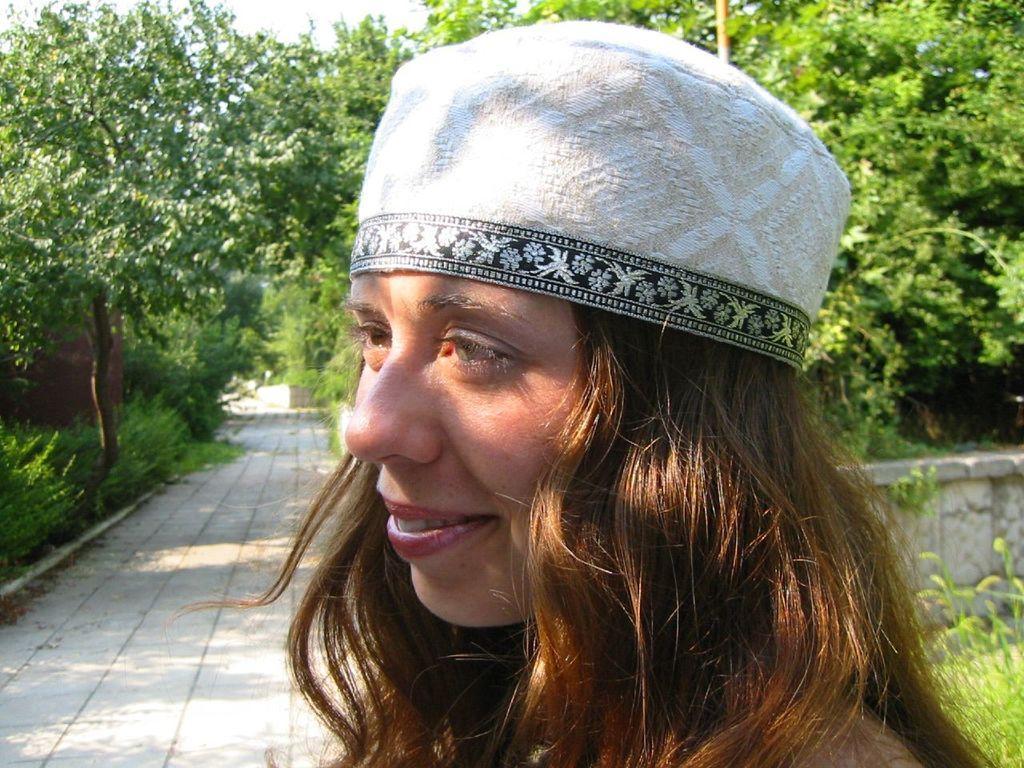How would you summarize this image in a sentence or two? In this image we can see a woman smiling. In the background there are trees,bushes, floor, walls and sky. 